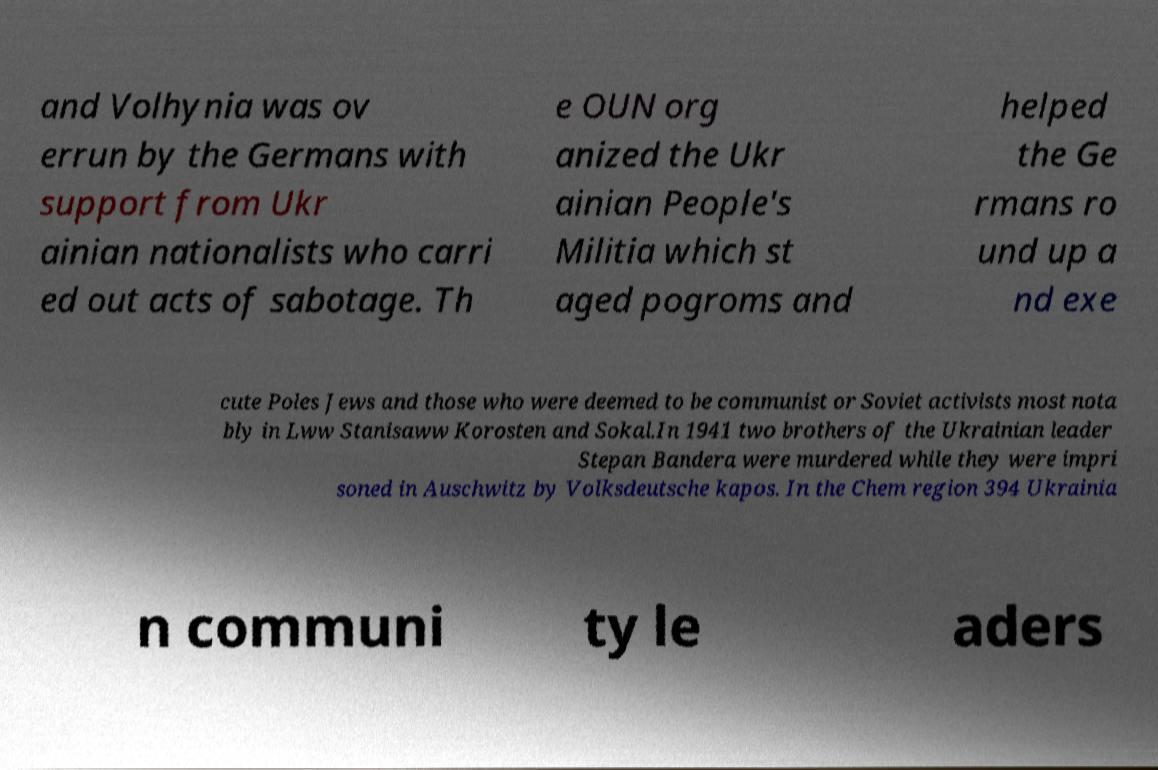For documentation purposes, I need the text within this image transcribed. Could you provide that? and Volhynia was ov errun by the Germans with support from Ukr ainian nationalists who carri ed out acts of sabotage. Th e OUN org anized the Ukr ainian People's Militia which st aged pogroms and helped the Ge rmans ro und up a nd exe cute Poles Jews and those who were deemed to be communist or Soviet activists most nota bly in Lww Stanisaww Korosten and Sokal.In 1941 two brothers of the Ukrainian leader Stepan Bandera were murdered while they were impri soned in Auschwitz by Volksdeutsche kapos. In the Chem region 394 Ukrainia n communi ty le aders 